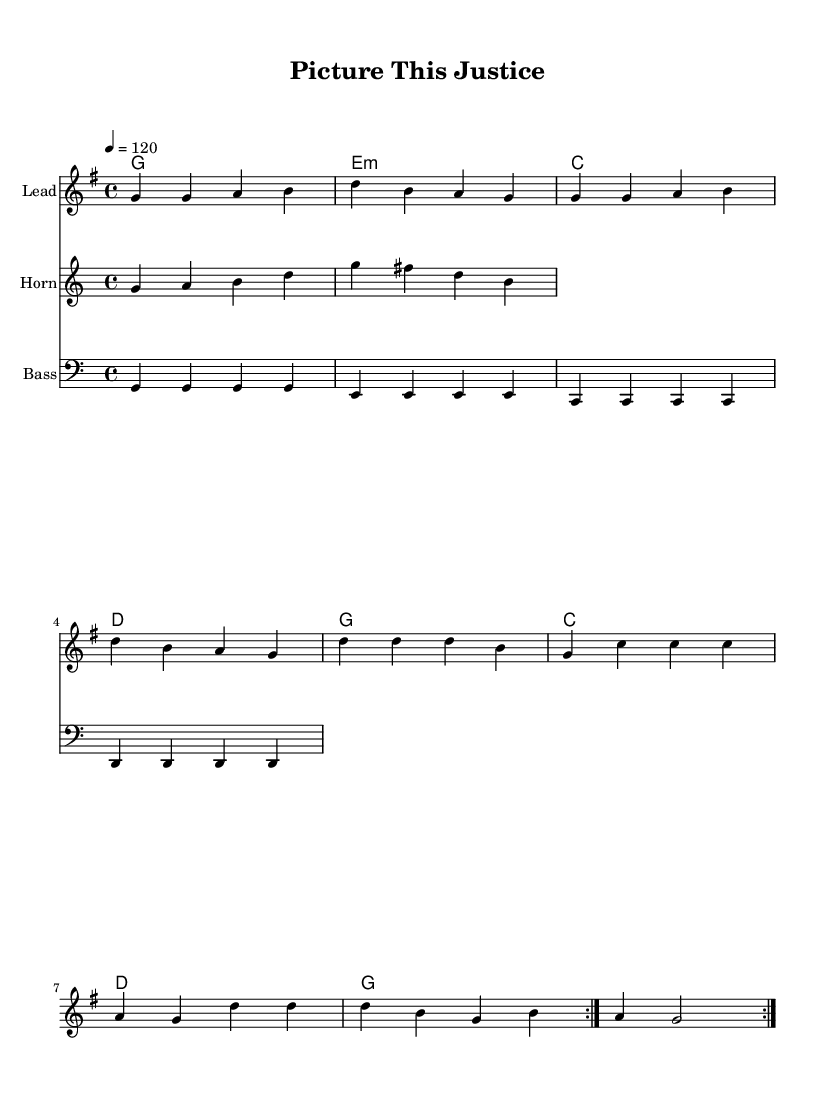What is the key signature of this music? The key signature is G major, which has one sharp (F#). This is identified by looking at the initial part of the staff where the sharps are indicated.
Answer: G major What is the time signature of this piece? The time signature is 4/4, which is evident from the fraction displayed at the beginning of the score. It indicates four beats per measure with the quarter note getting one beat.
Answer: 4/4 What is the tempo marking for this piece? The tempo marking is 120 beats per minute, which can be seen indicated in quarter note = 120. This specifies the speed at which the piece should be played.
Answer: 120 How many times is the main melody repeated? The main melody is repeated two times, as indicated by the "repeat volta 2" wording at the beginning of the melody section. This instruction guides the performer to play the melody twice before proceeding.
Answer: 2 What type of instrumental accompaniment is featured in this piece? The piece features piano (or chordal) accompaniment as indicated by the "ChordNames" and the structural setup in the score, which often accompanies the vocal line in soul music.
Answer: Piano Which visual aids are mentioned as supporting the lyrics in the courtroom context? The lyrics mention "diagrams, charts, and illustrations," which suggest the use of various visual aids to communicate complex ideas effectively in the courtroom, emphasizing the importance of visual communication.
Answer: Diagrams, charts, illustrations What genre does this piece belong to? The piece belongs to the soul genre, as indicated by the upbeat style and themes related to emotional expression and communication, which are characteristic of soul music.
Answer: Soul 